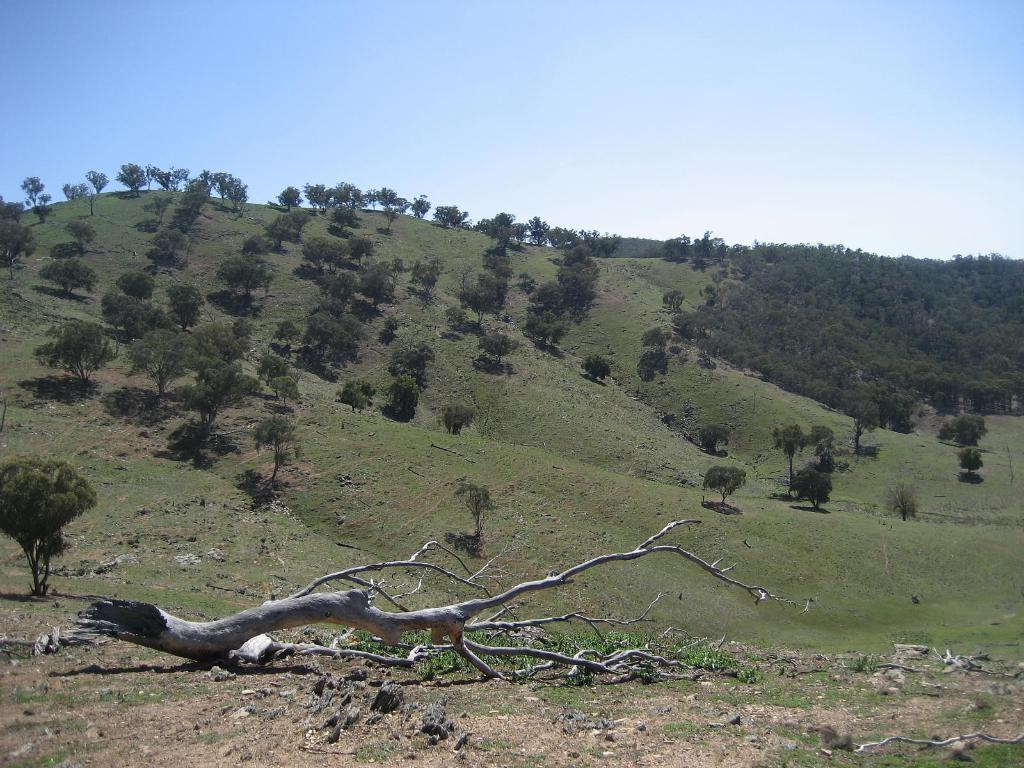What type of vegetation can be seen in the image? There is grass in the image. What other natural elements are present in the image? There are trees in the image. What can be seen in the background of the image? The sky is visible in the background of the image. Where is the kitten playing with the cannon in the image? There is no kitten or cannon present in the image. What type of gate can be seen in the image? There is no gate present in the image. 